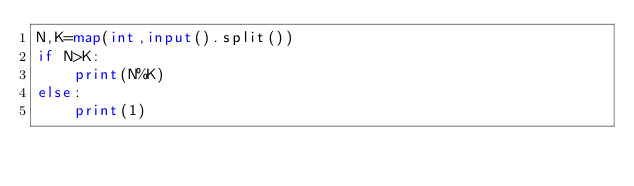Convert code to text. <code><loc_0><loc_0><loc_500><loc_500><_Python_>N,K=map(int,input().split())
if N>K:
    print(N%K)
else:
    print(1)
</code> 